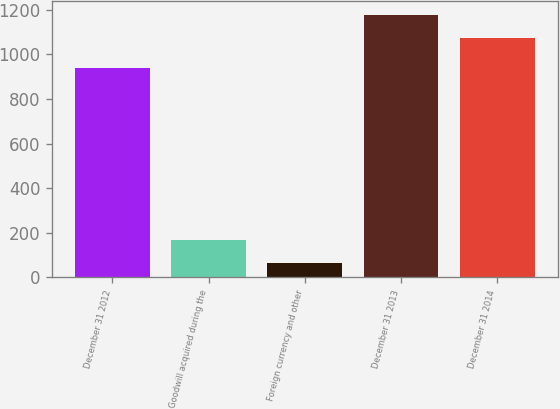Convert chart. <chart><loc_0><loc_0><loc_500><loc_500><bar_chart><fcel>December 31 2012<fcel>Goodwill acquired during the<fcel>Foreign currency and other<fcel>December 31 2013<fcel>December 31 2014<nl><fcel>938<fcel>169.6<fcel>65<fcel>1178.6<fcel>1074<nl></chart> 